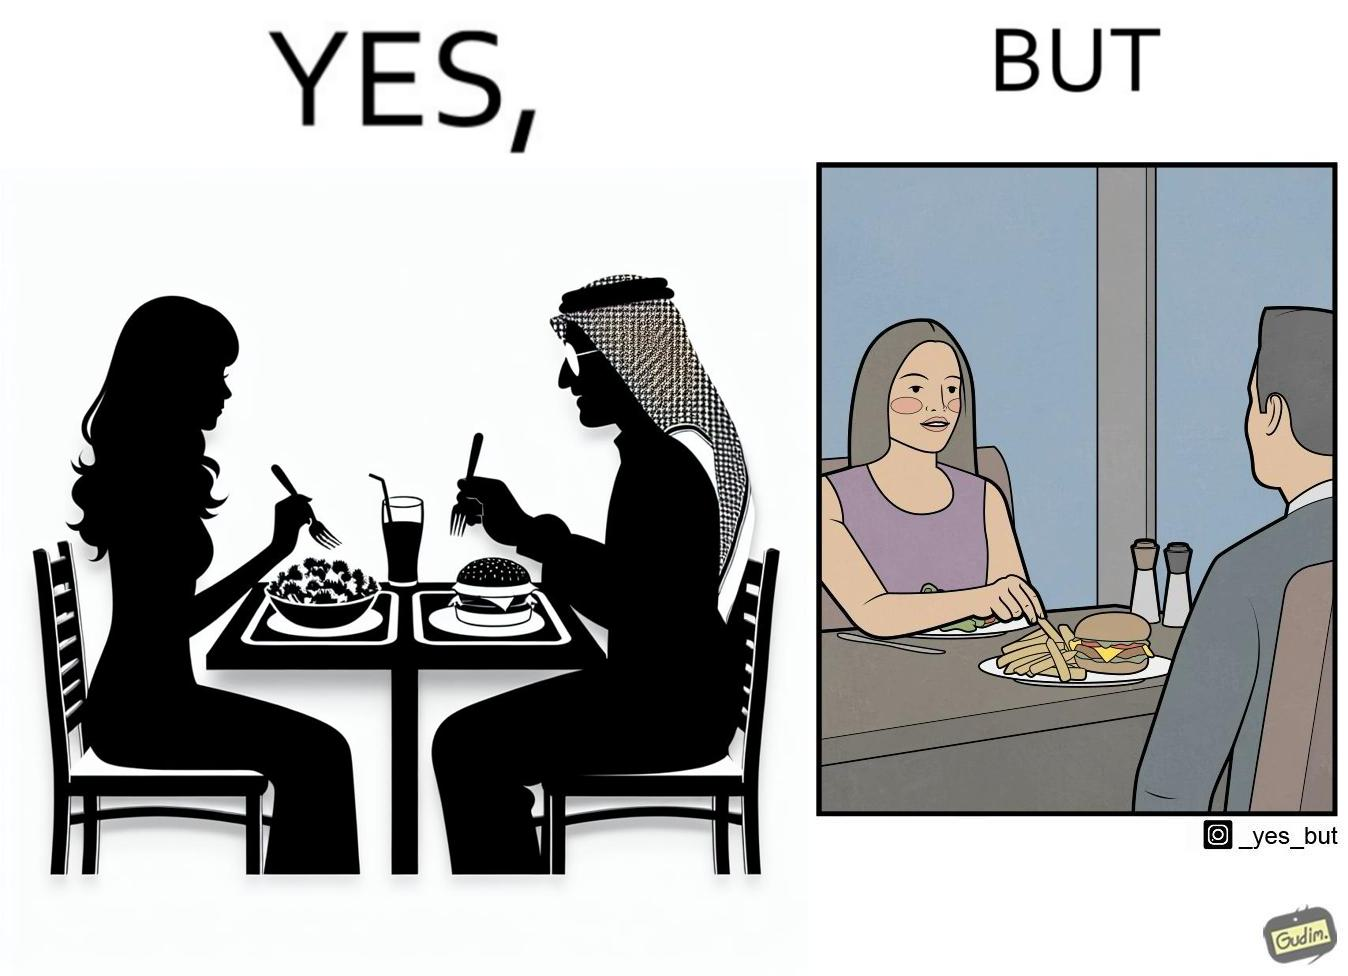Describe what you see in this image. The image is ironic because in the first image it is shown that the woman has got salad for her but she is having french fries from the man's plate which displays that the girl is trying to show herself as health conscious by having a plate of salad for her but she wants to have to have fast food but rather than having them for herself she is taking some from other's plate 